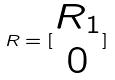Convert formula to latex. <formula><loc_0><loc_0><loc_500><loc_500>R = [ \begin{matrix} R _ { 1 } \\ 0 \end{matrix} ]</formula> 